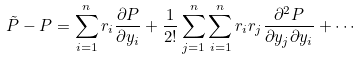Convert formula to latex. <formula><loc_0><loc_0><loc_500><loc_500>\tilde { P } - P = \sum ^ { n } _ { i = 1 } r _ { i } \frac { \partial P } { \partial y _ { i } } + \frac { 1 } { 2 ! } \sum ^ { n } _ { j = 1 } \sum ^ { n } _ { i = 1 } r _ { i } r _ { j } \frac { \partial ^ { 2 } P } { \partial y _ { j } \partial y _ { i } } + \cdots</formula> 